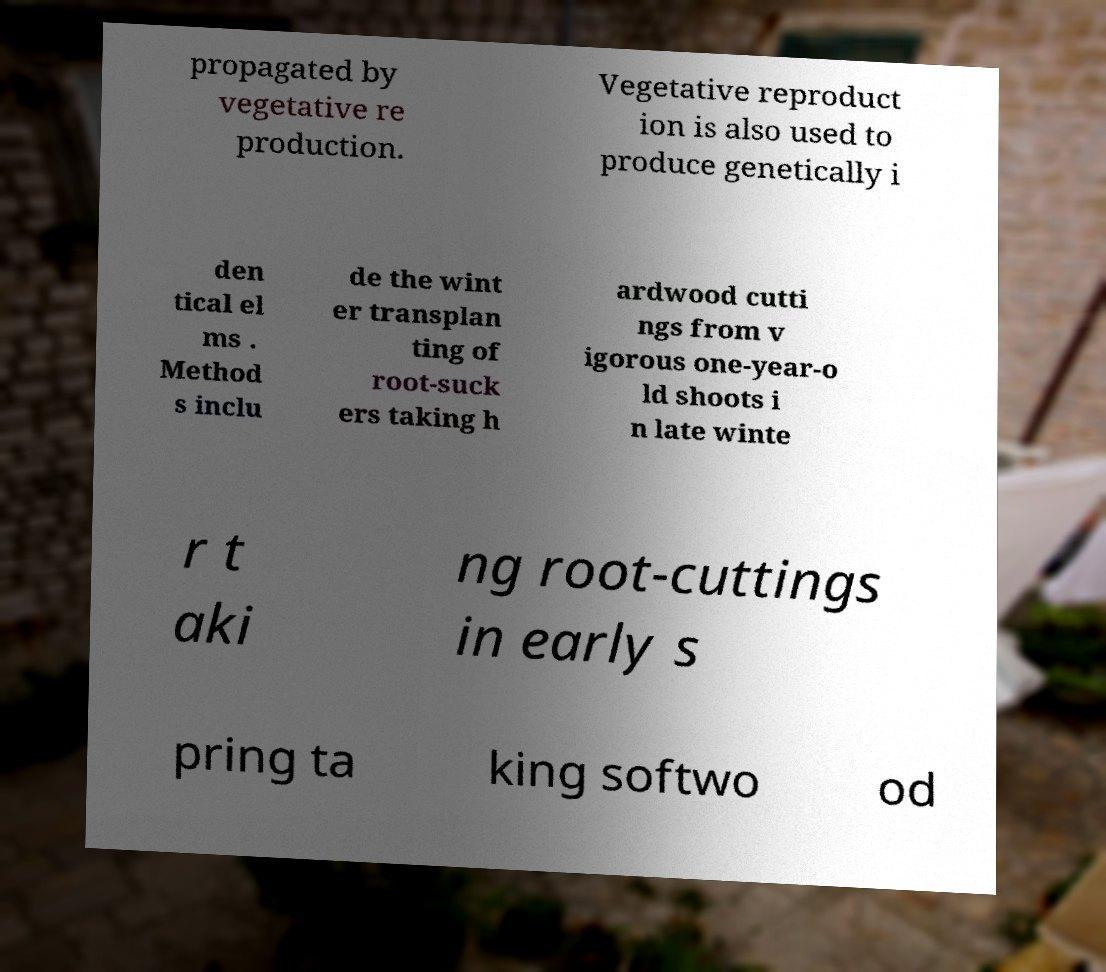I need the written content from this picture converted into text. Can you do that? propagated by vegetative re production. Vegetative reproduct ion is also used to produce genetically i den tical el ms . Method s inclu de the wint er transplan ting of root-suck ers taking h ardwood cutti ngs from v igorous one-year-o ld shoots i n late winte r t aki ng root-cuttings in early s pring ta king softwo od 